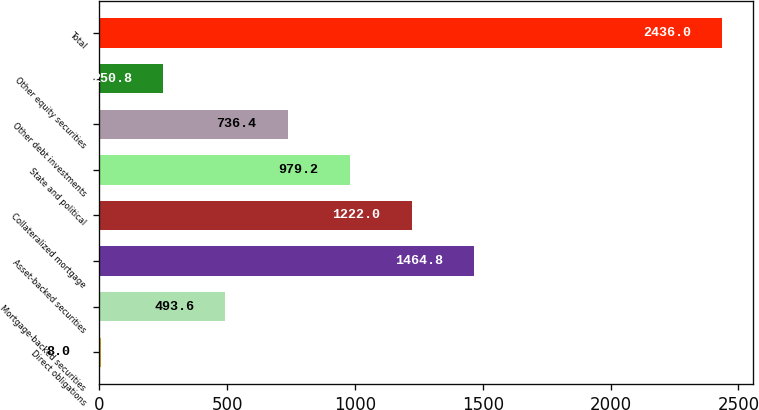<chart> <loc_0><loc_0><loc_500><loc_500><bar_chart><fcel>Direct obligations<fcel>Mortgage-backed securities<fcel>Asset-backed securities<fcel>Collateralized mortgage<fcel>State and political<fcel>Other debt investments<fcel>Other equity securities<fcel>Total<nl><fcel>8<fcel>493.6<fcel>1464.8<fcel>1222<fcel>979.2<fcel>736.4<fcel>250.8<fcel>2436<nl></chart> 